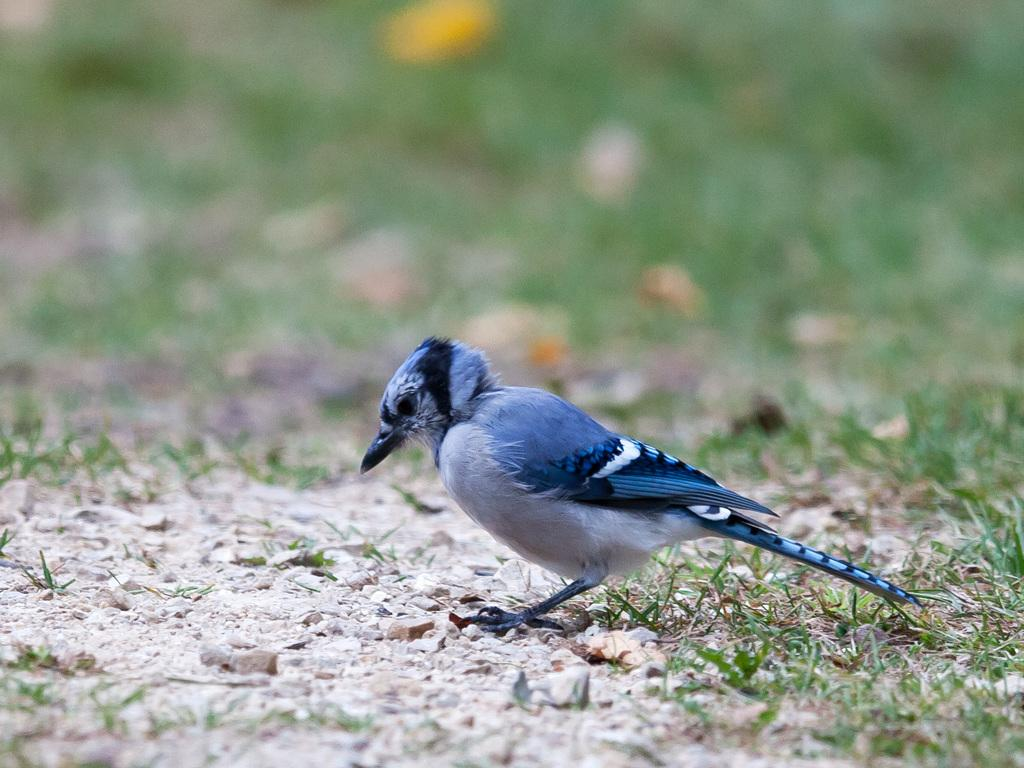What is the main subject in the center of the image? There is a bird in the center of the image. Where is the bird located? The bird is on the surface of something, possibly water or a flat surface. What other objects can be seen in the image? There are stones and grass visible in the image. How would you describe the background of the image? The background of the image is blurred. What type of volleyball game is being played in the background of the image? There is no volleyball game present in the image; it features a bird on a surface with stones and grass in the foreground. Can you tell me how many owls are visible in the image? There are no owls visible in the image; it features a bird that is not an owl. 